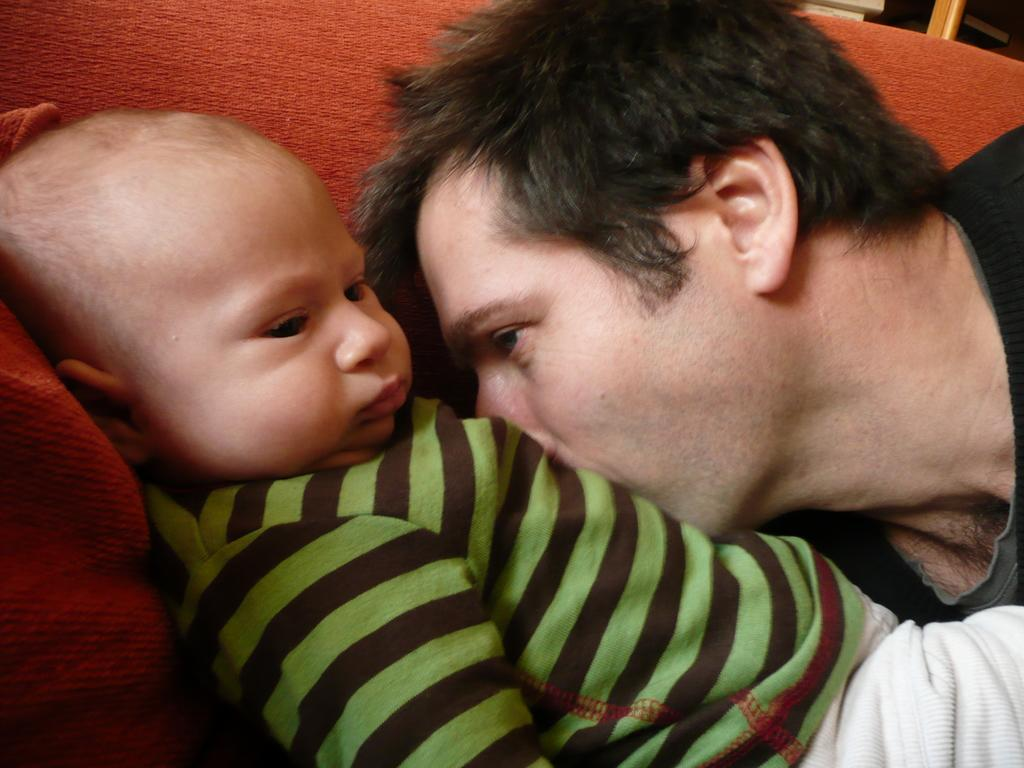Who is in the image? There is a man in the image. What is the man doing in the image? The man is kissing a kid. Where is the kid located in the image? The kid is sleeping on a bed. What can be seen in the background of the image? There is a sofa in the background of the image. What type of gun is the man holding in the image? There is no gun present in the image; the man is kissing a kid who is sleeping on a bed. 